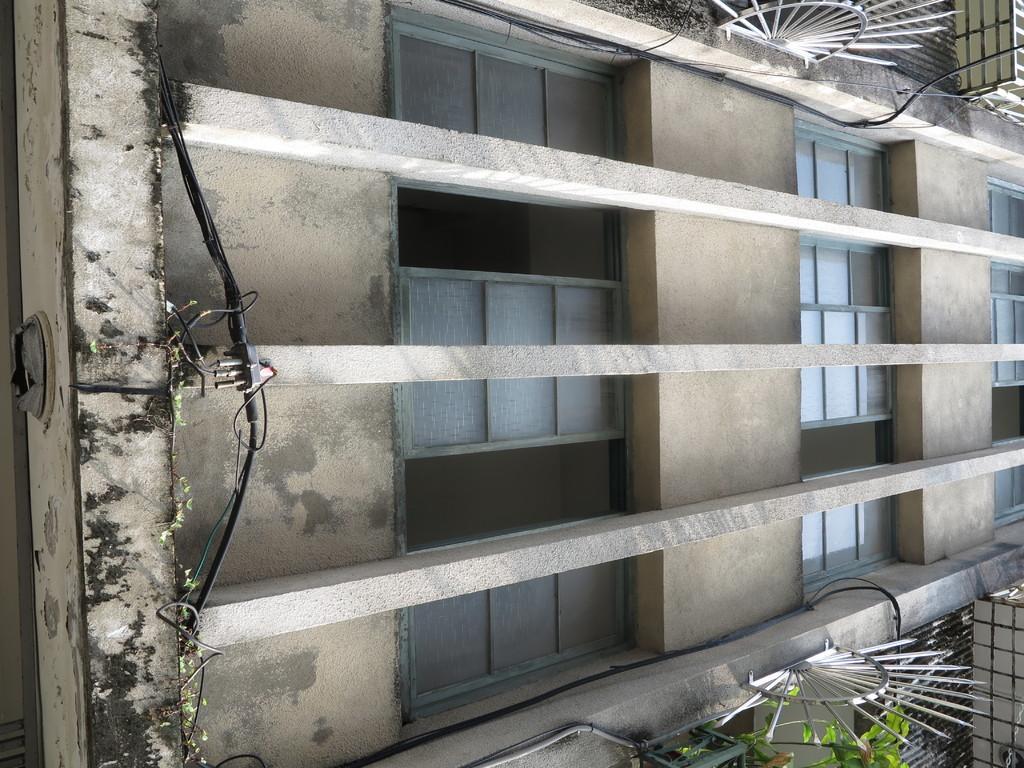Can you describe this image briefly? In this image we can see a wall of a building. On the building we can see the windows. On the left side, we can see a wire. In the top right, we can see a metal object and railing. In the bottom right we can see a wire, metal object, railing and a plant. 